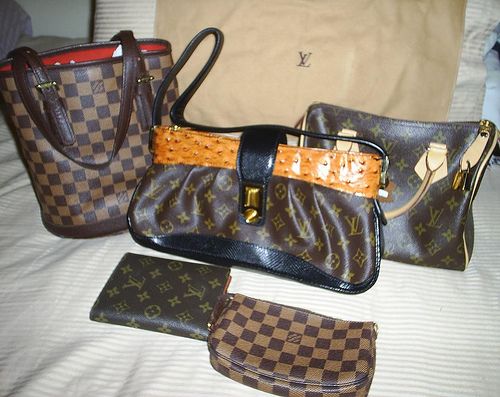<image>
Is the pillow behind the purse? Yes. From this viewpoint, the pillow is positioned behind the purse, with the purse partially or fully occluding the pillow. 